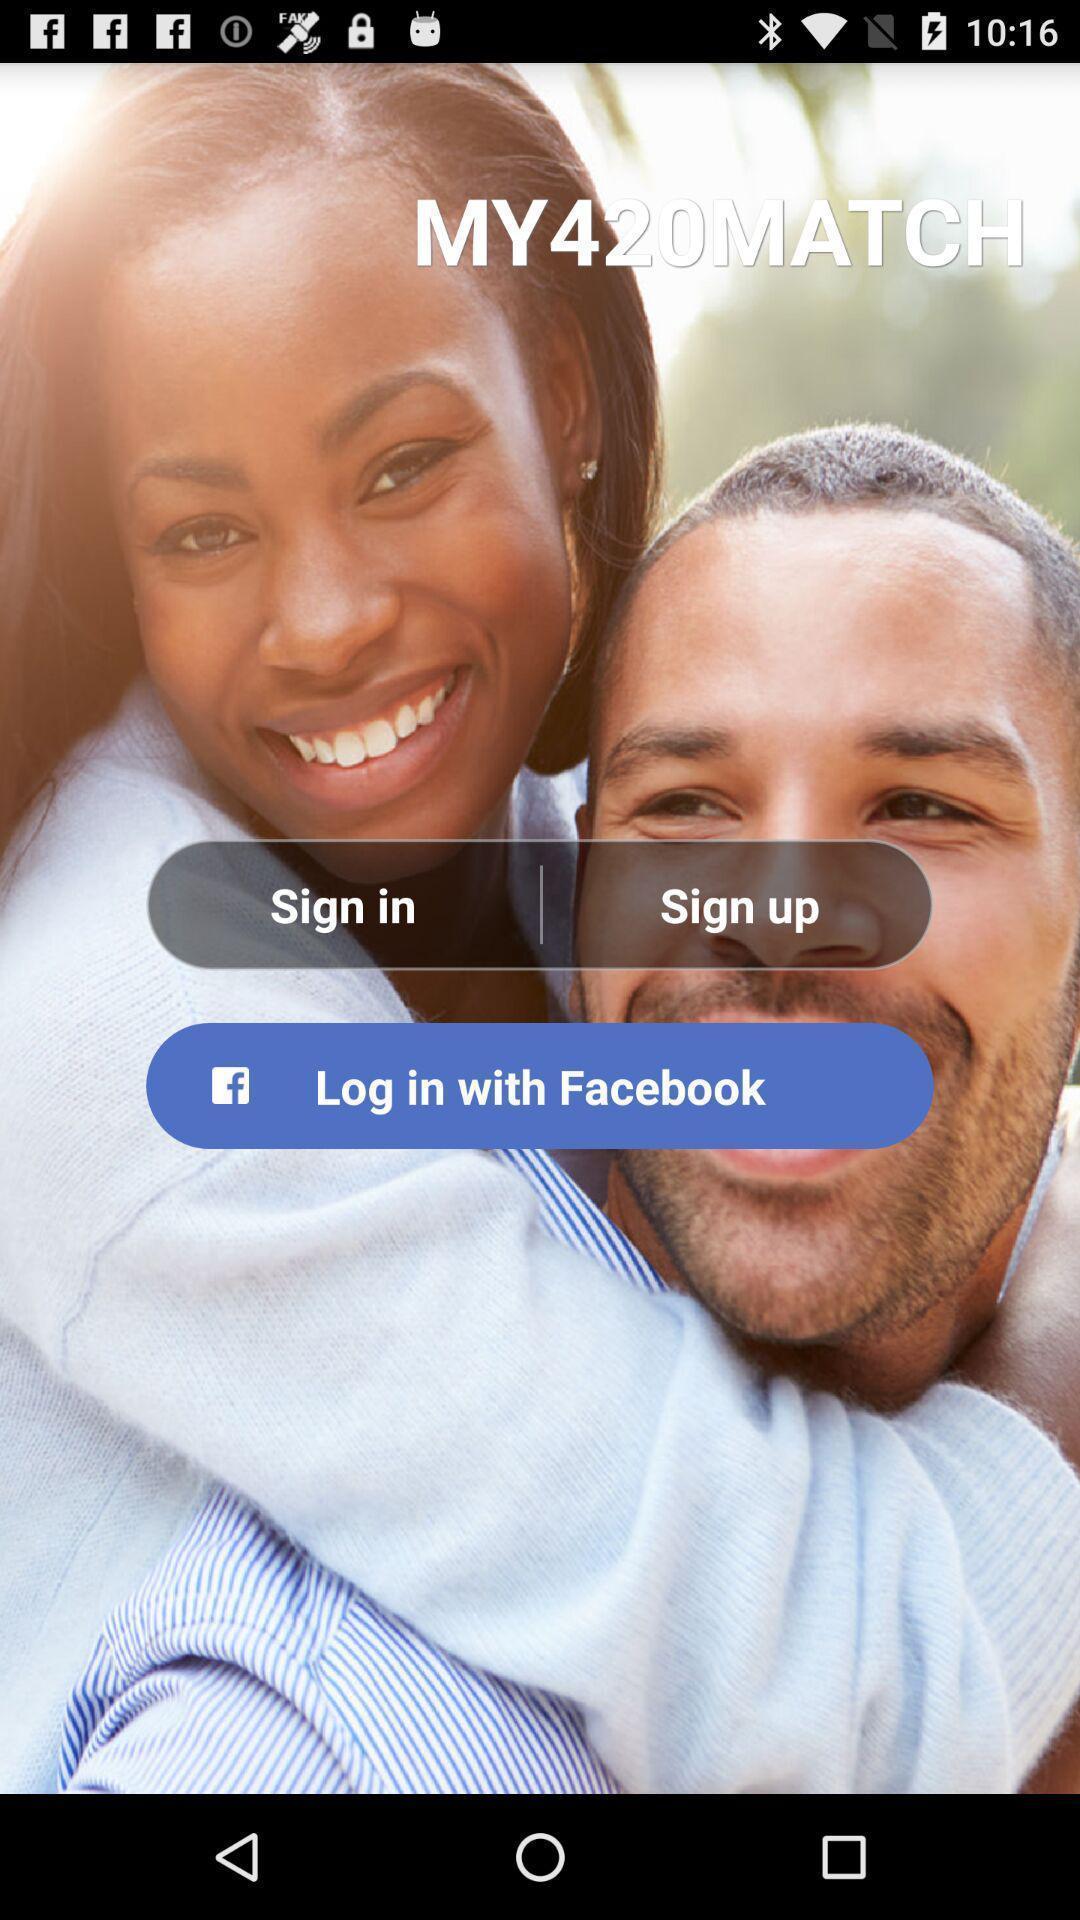Tell me about the visual elements in this screen capture. Sign up page. 